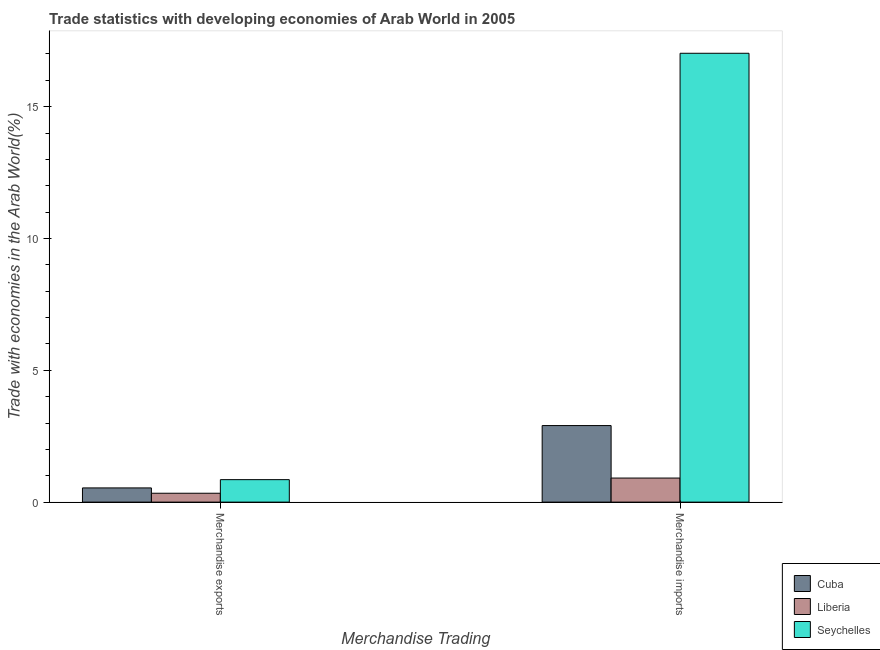How many different coloured bars are there?
Your answer should be very brief. 3. Are the number of bars per tick equal to the number of legend labels?
Offer a terse response. Yes. How many bars are there on the 2nd tick from the left?
Offer a very short reply. 3. How many bars are there on the 1st tick from the right?
Your answer should be very brief. 3. What is the merchandise exports in Cuba?
Offer a terse response. 0.54. Across all countries, what is the maximum merchandise imports?
Offer a very short reply. 17.03. Across all countries, what is the minimum merchandise exports?
Give a very brief answer. 0.34. In which country was the merchandise imports maximum?
Offer a very short reply. Seychelles. In which country was the merchandise exports minimum?
Provide a succinct answer. Liberia. What is the total merchandise imports in the graph?
Offer a terse response. 20.84. What is the difference between the merchandise exports in Cuba and that in Liberia?
Your answer should be very brief. 0.2. What is the difference between the merchandise imports in Cuba and the merchandise exports in Seychelles?
Make the answer very short. 2.05. What is the average merchandise imports per country?
Your answer should be very brief. 6.95. What is the difference between the merchandise exports and merchandise imports in Cuba?
Give a very brief answer. -2.36. In how many countries, is the merchandise imports greater than 12 %?
Keep it short and to the point. 1. What is the ratio of the merchandise exports in Cuba to that in Seychelles?
Your answer should be very brief. 0.63. In how many countries, is the merchandise imports greater than the average merchandise imports taken over all countries?
Provide a succinct answer. 1. What does the 2nd bar from the left in Merchandise exports represents?
Your answer should be very brief. Liberia. What does the 3rd bar from the right in Merchandise imports represents?
Your answer should be compact. Cuba. Are all the bars in the graph horizontal?
Provide a succinct answer. No. How many countries are there in the graph?
Provide a short and direct response. 3. What is the difference between two consecutive major ticks on the Y-axis?
Make the answer very short. 5. Are the values on the major ticks of Y-axis written in scientific E-notation?
Your response must be concise. No. Does the graph contain any zero values?
Ensure brevity in your answer.  No. Where does the legend appear in the graph?
Your answer should be very brief. Bottom right. How are the legend labels stacked?
Make the answer very short. Vertical. What is the title of the graph?
Offer a terse response. Trade statistics with developing economies of Arab World in 2005. Does "Netherlands" appear as one of the legend labels in the graph?
Your response must be concise. No. What is the label or title of the X-axis?
Give a very brief answer. Merchandise Trading. What is the label or title of the Y-axis?
Make the answer very short. Trade with economies in the Arab World(%). What is the Trade with economies in the Arab World(%) of Cuba in Merchandise exports?
Offer a terse response. 0.54. What is the Trade with economies in the Arab World(%) in Liberia in Merchandise exports?
Your answer should be compact. 0.34. What is the Trade with economies in the Arab World(%) in Seychelles in Merchandise exports?
Offer a terse response. 0.85. What is the Trade with economies in the Arab World(%) in Cuba in Merchandise imports?
Make the answer very short. 2.9. What is the Trade with economies in the Arab World(%) in Liberia in Merchandise imports?
Ensure brevity in your answer.  0.91. What is the Trade with economies in the Arab World(%) of Seychelles in Merchandise imports?
Provide a short and direct response. 17.03. Across all Merchandise Trading, what is the maximum Trade with economies in the Arab World(%) of Cuba?
Offer a terse response. 2.9. Across all Merchandise Trading, what is the maximum Trade with economies in the Arab World(%) of Liberia?
Offer a terse response. 0.91. Across all Merchandise Trading, what is the maximum Trade with economies in the Arab World(%) in Seychelles?
Your answer should be very brief. 17.03. Across all Merchandise Trading, what is the minimum Trade with economies in the Arab World(%) of Cuba?
Make the answer very short. 0.54. Across all Merchandise Trading, what is the minimum Trade with economies in the Arab World(%) in Liberia?
Offer a terse response. 0.34. Across all Merchandise Trading, what is the minimum Trade with economies in the Arab World(%) of Seychelles?
Give a very brief answer. 0.85. What is the total Trade with economies in the Arab World(%) in Cuba in the graph?
Your answer should be very brief. 3.44. What is the total Trade with economies in the Arab World(%) in Liberia in the graph?
Ensure brevity in your answer.  1.25. What is the total Trade with economies in the Arab World(%) in Seychelles in the graph?
Make the answer very short. 17.88. What is the difference between the Trade with economies in the Arab World(%) of Cuba in Merchandise exports and that in Merchandise imports?
Keep it short and to the point. -2.36. What is the difference between the Trade with economies in the Arab World(%) of Liberia in Merchandise exports and that in Merchandise imports?
Ensure brevity in your answer.  -0.58. What is the difference between the Trade with economies in the Arab World(%) in Seychelles in Merchandise exports and that in Merchandise imports?
Your response must be concise. -16.17. What is the difference between the Trade with economies in the Arab World(%) in Cuba in Merchandise exports and the Trade with economies in the Arab World(%) in Liberia in Merchandise imports?
Provide a succinct answer. -0.37. What is the difference between the Trade with economies in the Arab World(%) of Cuba in Merchandise exports and the Trade with economies in the Arab World(%) of Seychelles in Merchandise imports?
Your answer should be compact. -16.49. What is the difference between the Trade with economies in the Arab World(%) of Liberia in Merchandise exports and the Trade with economies in the Arab World(%) of Seychelles in Merchandise imports?
Ensure brevity in your answer.  -16.69. What is the average Trade with economies in the Arab World(%) of Cuba per Merchandise Trading?
Provide a short and direct response. 1.72. What is the average Trade with economies in the Arab World(%) in Liberia per Merchandise Trading?
Offer a terse response. 0.62. What is the average Trade with economies in the Arab World(%) of Seychelles per Merchandise Trading?
Make the answer very short. 8.94. What is the difference between the Trade with economies in the Arab World(%) of Cuba and Trade with economies in the Arab World(%) of Liberia in Merchandise exports?
Your response must be concise. 0.2. What is the difference between the Trade with economies in the Arab World(%) of Cuba and Trade with economies in the Arab World(%) of Seychelles in Merchandise exports?
Ensure brevity in your answer.  -0.31. What is the difference between the Trade with economies in the Arab World(%) in Liberia and Trade with economies in the Arab World(%) in Seychelles in Merchandise exports?
Provide a succinct answer. -0.52. What is the difference between the Trade with economies in the Arab World(%) in Cuba and Trade with economies in the Arab World(%) in Liberia in Merchandise imports?
Keep it short and to the point. 1.99. What is the difference between the Trade with economies in the Arab World(%) of Cuba and Trade with economies in the Arab World(%) of Seychelles in Merchandise imports?
Keep it short and to the point. -14.12. What is the difference between the Trade with economies in the Arab World(%) of Liberia and Trade with economies in the Arab World(%) of Seychelles in Merchandise imports?
Your answer should be very brief. -16.11. What is the ratio of the Trade with economies in the Arab World(%) of Cuba in Merchandise exports to that in Merchandise imports?
Your response must be concise. 0.19. What is the ratio of the Trade with economies in the Arab World(%) of Liberia in Merchandise exports to that in Merchandise imports?
Make the answer very short. 0.37. What is the ratio of the Trade with economies in the Arab World(%) in Seychelles in Merchandise exports to that in Merchandise imports?
Your response must be concise. 0.05. What is the difference between the highest and the second highest Trade with economies in the Arab World(%) of Cuba?
Keep it short and to the point. 2.36. What is the difference between the highest and the second highest Trade with economies in the Arab World(%) of Liberia?
Provide a succinct answer. 0.58. What is the difference between the highest and the second highest Trade with economies in the Arab World(%) in Seychelles?
Offer a terse response. 16.17. What is the difference between the highest and the lowest Trade with economies in the Arab World(%) of Cuba?
Provide a short and direct response. 2.36. What is the difference between the highest and the lowest Trade with economies in the Arab World(%) of Liberia?
Offer a terse response. 0.58. What is the difference between the highest and the lowest Trade with economies in the Arab World(%) of Seychelles?
Provide a succinct answer. 16.17. 